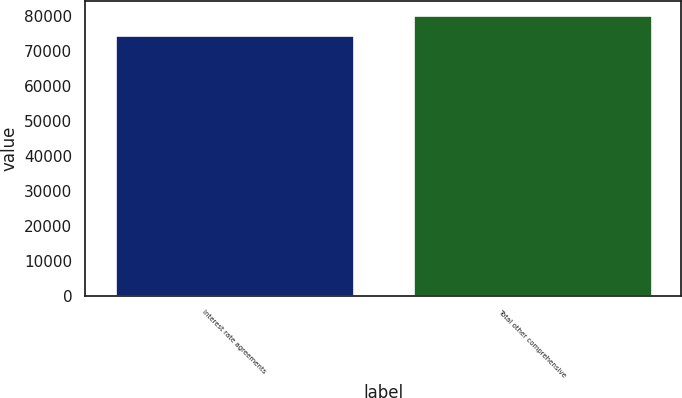Convert chart. <chart><loc_0><loc_0><loc_500><loc_500><bar_chart><fcel>Interest rate agreements<fcel>Total other comprehensive<nl><fcel>74560<fcel>80204<nl></chart> 